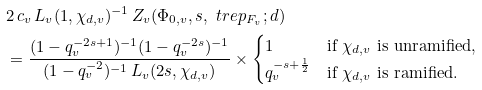<formula> <loc_0><loc_0><loc_500><loc_500>& 2 \, c _ { v } \, L _ { v } ( 1 , \chi _ { d , v } ) ^ { - 1 } \, Z _ { v } ( \Phi _ { 0 , v } , s , \ t r e p _ { F _ { v } } ; d ) \\ & = \frac { ( 1 - q _ { v } ^ { - 2 s + 1 } ) ^ { - 1 } ( 1 - q _ { v } ^ { - 2 s } ) ^ { - 1 } } { ( 1 - q _ { v } ^ { - 2 } ) ^ { - 1 } \, L _ { v } ( 2 s , \chi _ { d , v } ) } \times \begin{cases} 1 & \text {if $\chi_{d,v}$ is unramified} , \\ q _ { v } ^ { - s + \frac { 1 } { 2 } } & \text {if $\chi_{d,v}$ is ramified} . \end{cases}</formula> 